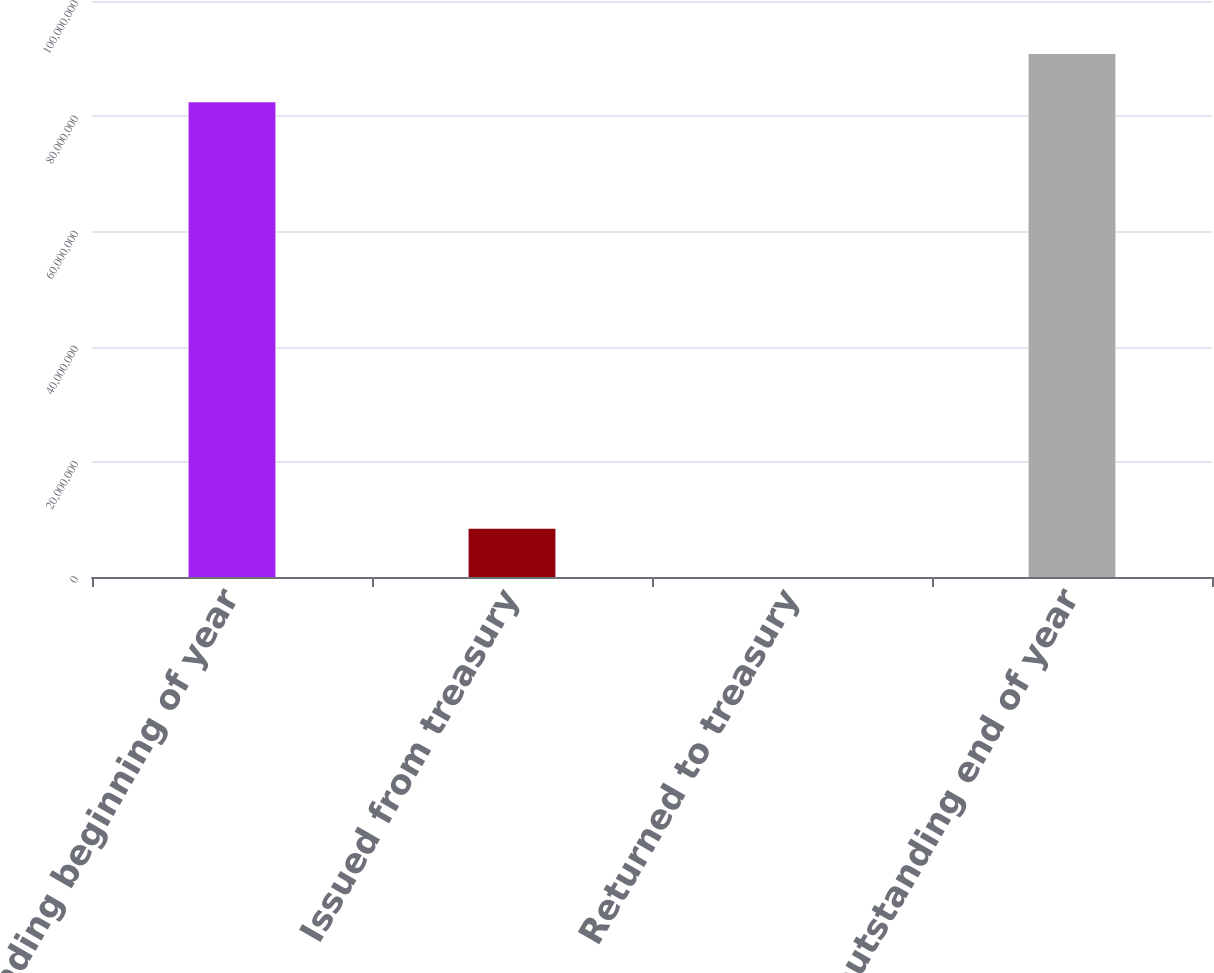Convert chart to OTSL. <chart><loc_0><loc_0><loc_500><loc_500><bar_chart><fcel>outstanding beginning of year<fcel>Issued from treasury<fcel>Returned to treasury<fcel>outstanding end of year<nl><fcel>8.24071e+07<fcel>8.38281e+06<fcel>4113<fcel>9.07858e+07<nl></chart> 